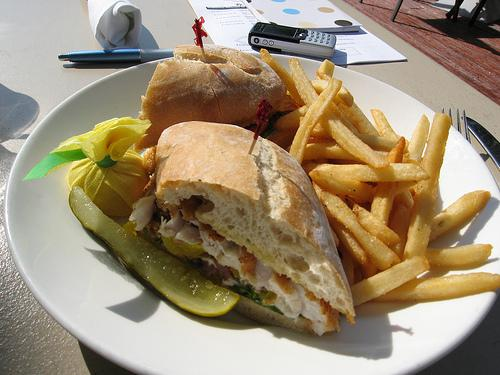Count the number of objects within the image, including duplicates. There are 39 objects in the image. Can you identify a mobile phone in the picture and describe its location? Yes, there is a black and grey mobile phone placed on the table near some papers. In terms of width, which is the widest object in the image? "Half a sandwich on plate" with width 238 is the widest object in the image. What is the most dominant food item presented on the plate? The most dominant food item is the sandwich cut in half. Which object appears to be the smallest in terms of height? Part of a fork with height 2 is the smallest object in terms of height. Which objects are directly touching the table? Pen, mobile phone, ink pen, and papers are directly touching the table. Please list the objects related to utensils and their placements. 4. Prongs of a fork - near the plate Can you describe the overall sentiment conveyed by the image? The image conveys a positive, casual sentiment of a person enjoying a meal while having access to their belongings like phone and pen. Describe the writing instrument that's placed on the table. The writing instrument is a blue pen that's lying on the wooden table. Note the three freshly baked cookies served on the round white plate, right above the golden french fries. There is no mention of any cookies in the image detail data, so this declarative sentence offers false instructions by describing nonexistent objects placed relative to another object within the image. Find the small green plant on the windowsill situated in the corner of the wooden floor. There is no mention of a windowsill, plant, or corner in the provided image data, so this instruction is directing the viewer to look for an object in a location that does not exist within the image. Can you spot the bright red apple in the picture? It's nestled next to the sandwiches on the plate. There is no mention of an apple in the given image information, and this instruction leads the viewer to search for a nonexistent object with a specific color and location. Please identify the large glass of orange juice sitting on the table near the mobile phone. No information about any glass or orange juice is provided in the image details. This instruction is misleading because it asks to locate a nonexistent item near another existing object. Observe the stack of books to the left of the wooden floor and count how many there are. No books are mentioned in the image details, making it impossible for the viewer to complete the task. Additionally, the interrogative nature of the sentence ("count how many there are") adds an extra layer of misleading information. Is there a fluffy, blue throw pillow resting on the chair in front of the table? No chair or pillow is mentioned in the image data, and this interrogative sentence misleads the viewer by asking them to consider and locate non-existent objects within the scene. 